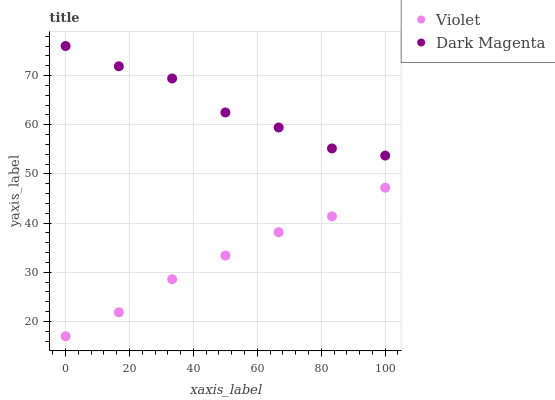Does Violet have the minimum area under the curve?
Answer yes or no. Yes. Does Dark Magenta have the maximum area under the curve?
Answer yes or no. Yes. Does Violet have the maximum area under the curve?
Answer yes or no. No. Is Violet the smoothest?
Answer yes or no. Yes. Is Dark Magenta the roughest?
Answer yes or no. Yes. Is Violet the roughest?
Answer yes or no. No. Does Violet have the lowest value?
Answer yes or no. Yes. Does Dark Magenta have the highest value?
Answer yes or no. Yes. Does Violet have the highest value?
Answer yes or no. No. Is Violet less than Dark Magenta?
Answer yes or no. Yes. Is Dark Magenta greater than Violet?
Answer yes or no. Yes. Does Violet intersect Dark Magenta?
Answer yes or no. No. 